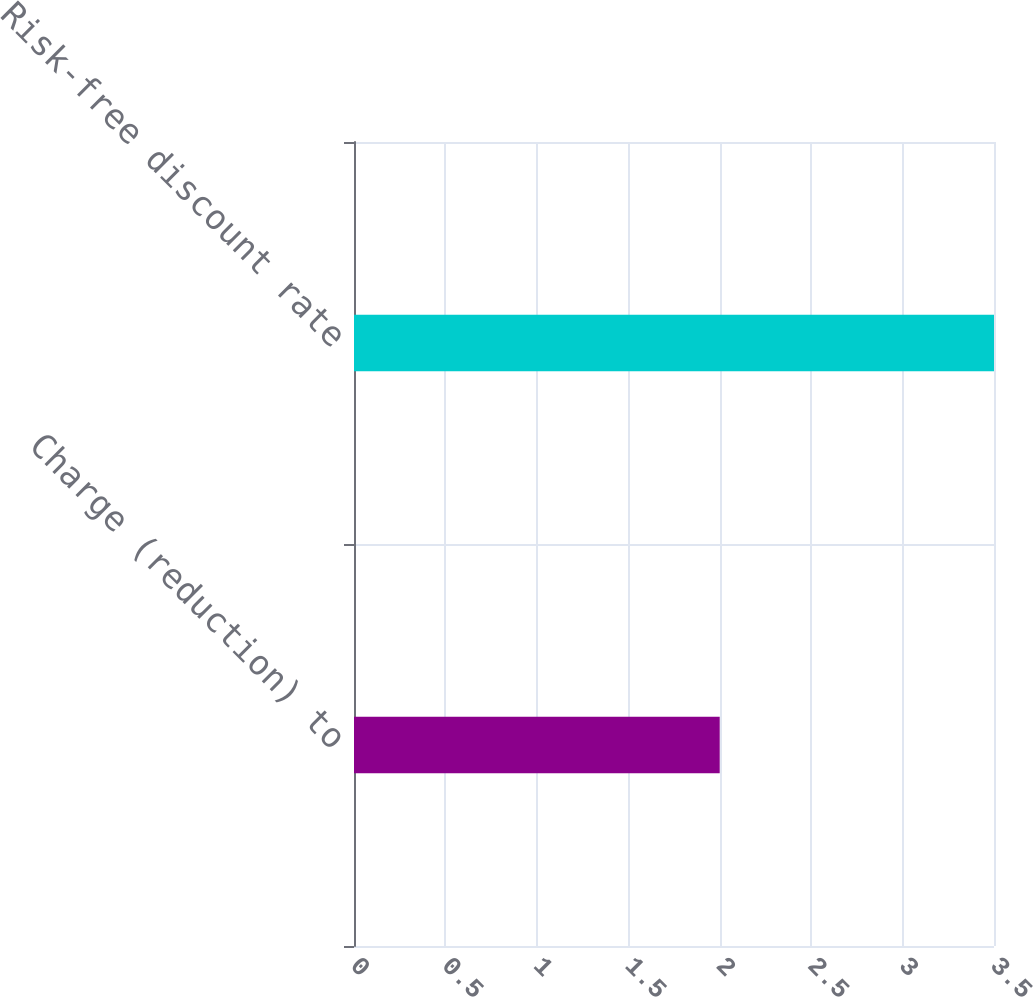Convert chart. <chart><loc_0><loc_0><loc_500><loc_500><bar_chart><fcel>Charge (reduction) to<fcel>Risk-free discount rate<nl><fcel>2<fcel>3.5<nl></chart> 